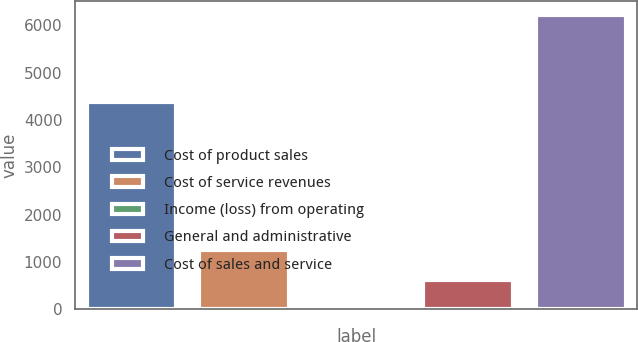<chart> <loc_0><loc_0><loc_500><loc_500><bar_chart><fcel>Cost of product sales<fcel>Cost of service revenues<fcel>Income (loss) from operating<fcel>General and administrative<fcel>Cost of sales and service<nl><fcel>4380<fcel>1246.8<fcel>6<fcel>626.4<fcel>6210<nl></chart> 